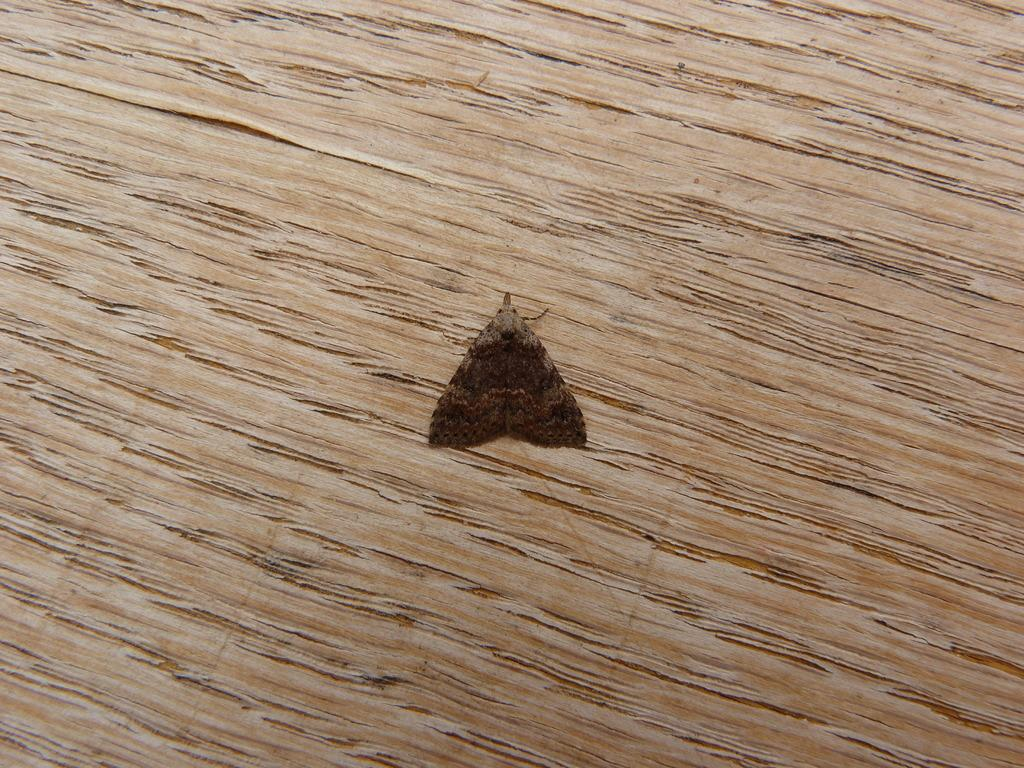What type of creature can be seen in the picture? There is an insect in the picture. What is the surface at the bottom of the picture? There is a wooden floor at the bottom of the picture. What type of scale is used to weigh the insect in the picture? There is no scale present in the image, and the insect's weight is not mentioned or depicted. 